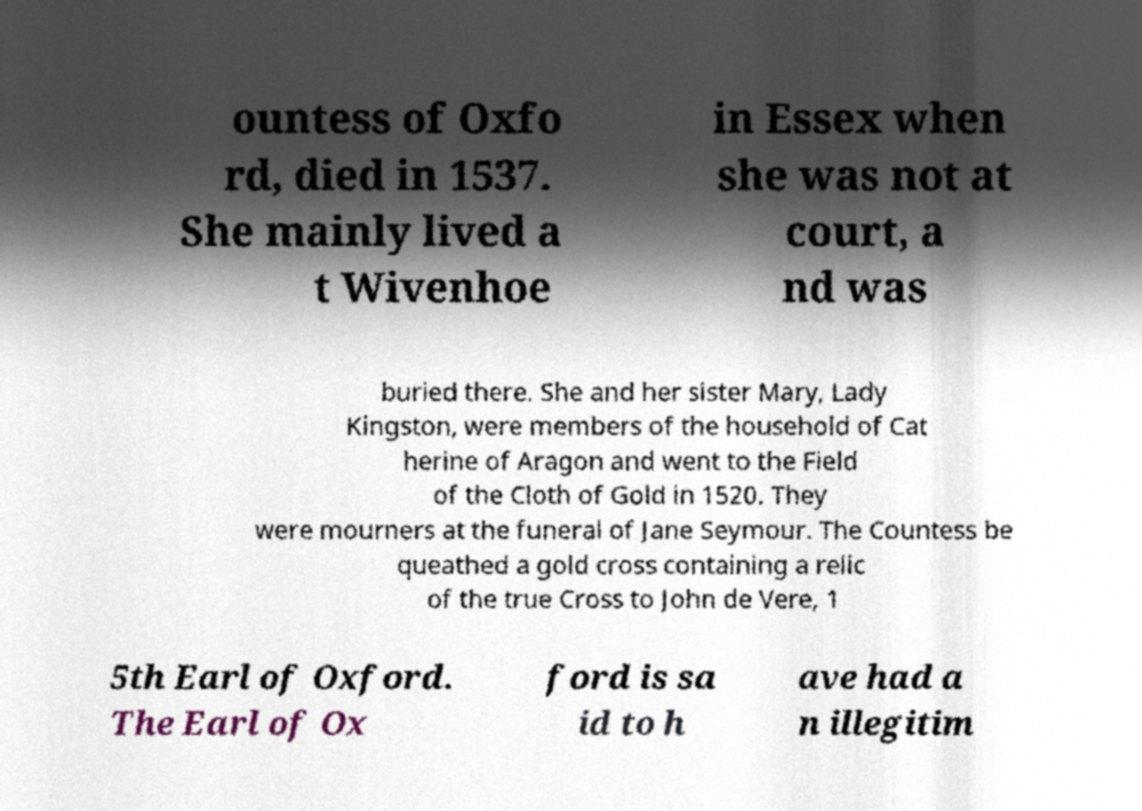Please identify and transcribe the text found in this image. ountess of Oxfo rd, died in 1537. She mainly lived a t Wivenhoe in Essex when she was not at court, a nd was buried there. She and her sister Mary, Lady Kingston, were members of the household of Cat herine of Aragon and went to the Field of the Cloth of Gold in 1520. They were mourners at the funeral of Jane Seymour. The Countess be queathed a gold cross containing a relic of the true Cross to John de Vere, 1 5th Earl of Oxford. The Earl of Ox ford is sa id to h ave had a n illegitim 